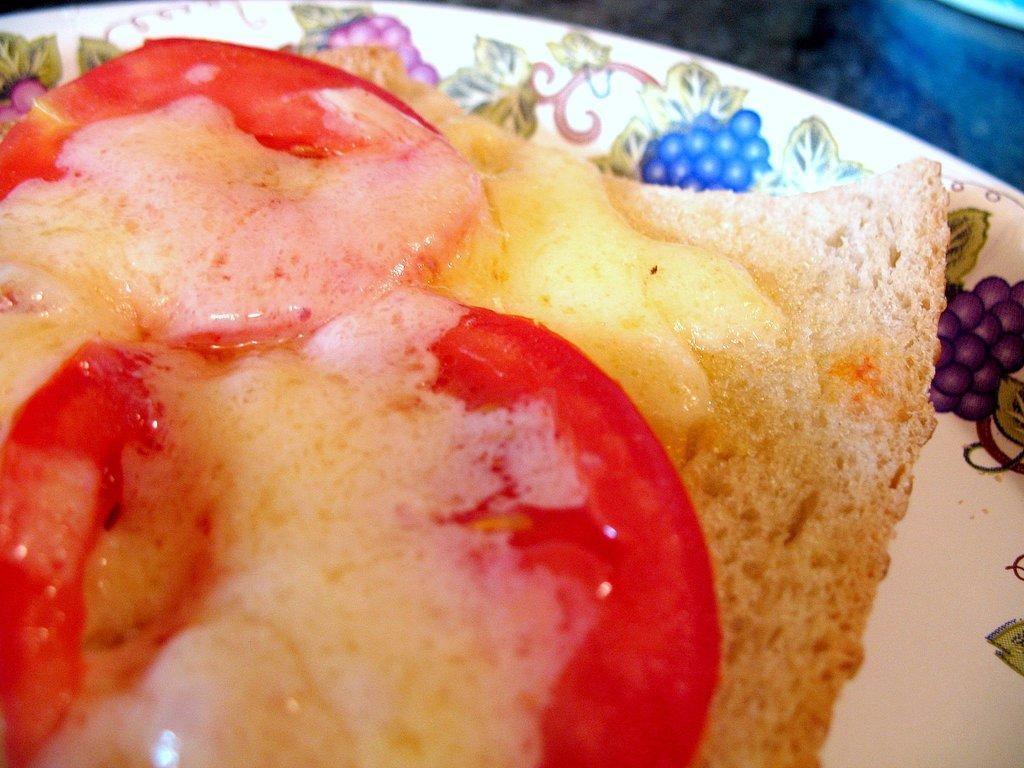Describe this image in one or two sentences. This image consists of a sandwich kept in a plate. And we can see the tomatoes and bread. The plate is in white color. 